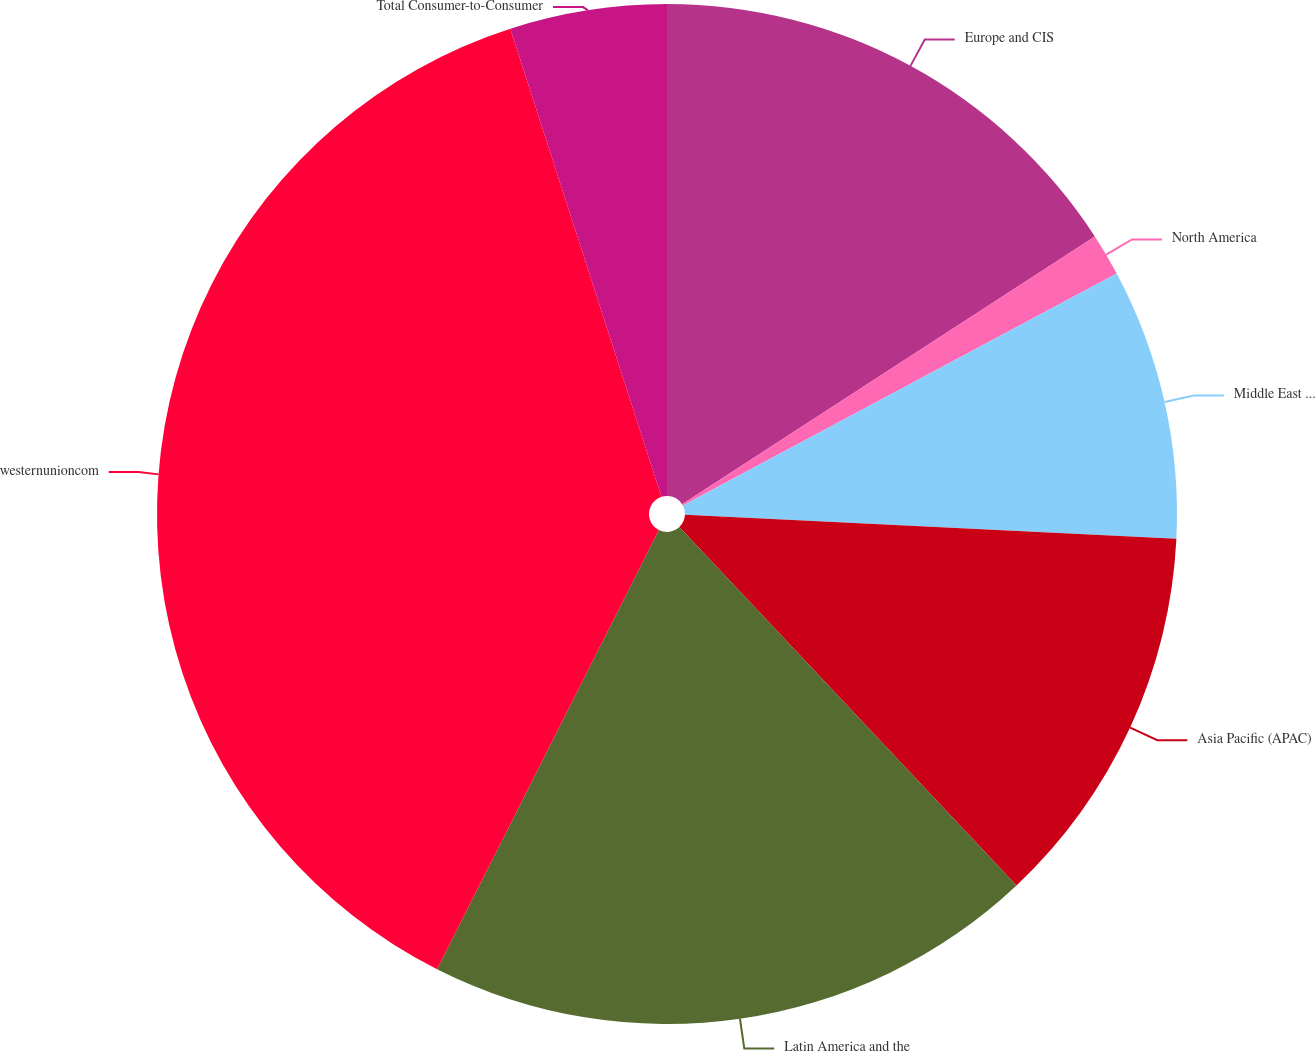<chart> <loc_0><loc_0><loc_500><loc_500><pie_chart><fcel>Europe and CIS<fcel>North America<fcel>Middle East and Africa<fcel>Asia Pacific (APAC)<fcel>Latin America and the<fcel>westernunioncom<fcel>Total Consumer-to-Consumer<nl><fcel>15.84%<fcel>1.34%<fcel>8.59%<fcel>12.21%<fcel>19.46%<fcel>37.58%<fcel>4.97%<nl></chart> 